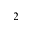Convert formula to latex. <formula><loc_0><loc_0><loc_500><loc_500>_ { 2 }</formula> 